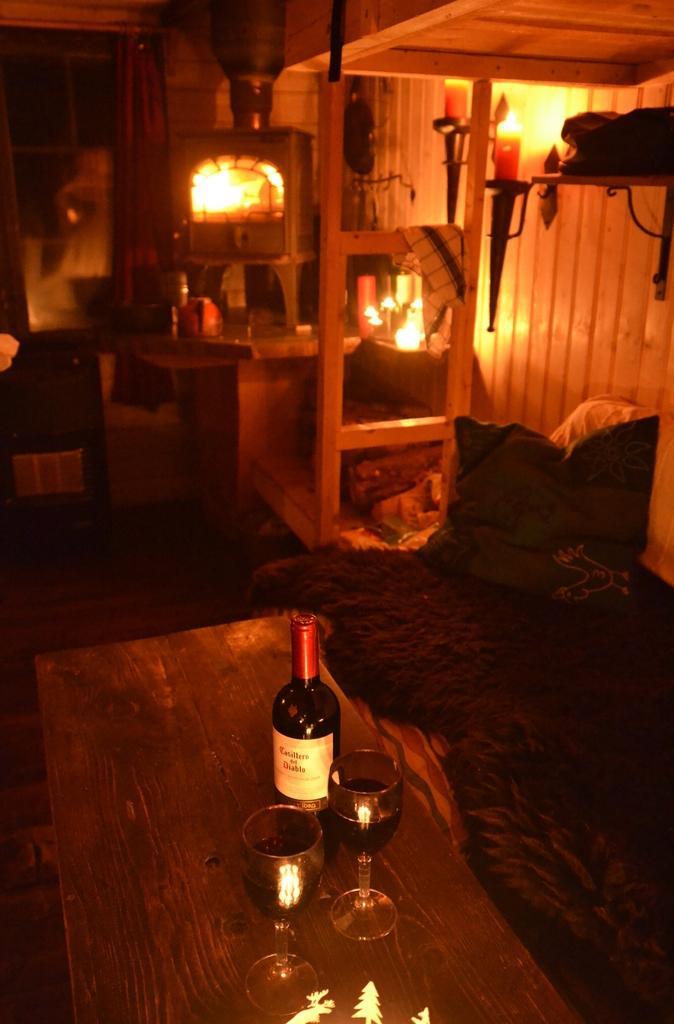Can you describe this image briefly? Inside picture of a room. Front there is a table. Above the table there is a bottle and glasses. Beside this table there is a bed with pillow. Light is attached with the wall. Cloth is on the ladder. 